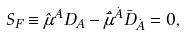<formula> <loc_0><loc_0><loc_500><loc_500>S _ { F } \equiv \hat { \mu } ^ { A } D _ { A } - \hat { \bar { \mu } } ^ { \dot { A } } \bar { D } _ { \dot { A } } = 0 ,</formula> 